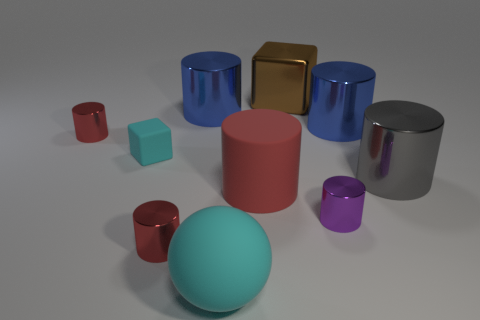How many red cylinders must be subtracted to get 1 red cylinders? 2 Subtract all green blocks. How many red cylinders are left? 3 Subtract all purple cylinders. How many cylinders are left? 6 Subtract all rubber cylinders. How many cylinders are left? 6 Subtract all yellow cylinders. Subtract all red balls. How many cylinders are left? 7 Subtract all cylinders. How many objects are left? 3 Add 8 large cyan spheres. How many large cyan spheres are left? 9 Add 6 brown shiny things. How many brown shiny things exist? 7 Subtract 1 purple cylinders. How many objects are left? 9 Subtract all small brown matte blocks. Subtract all purple objects. How many objects are left? 9 